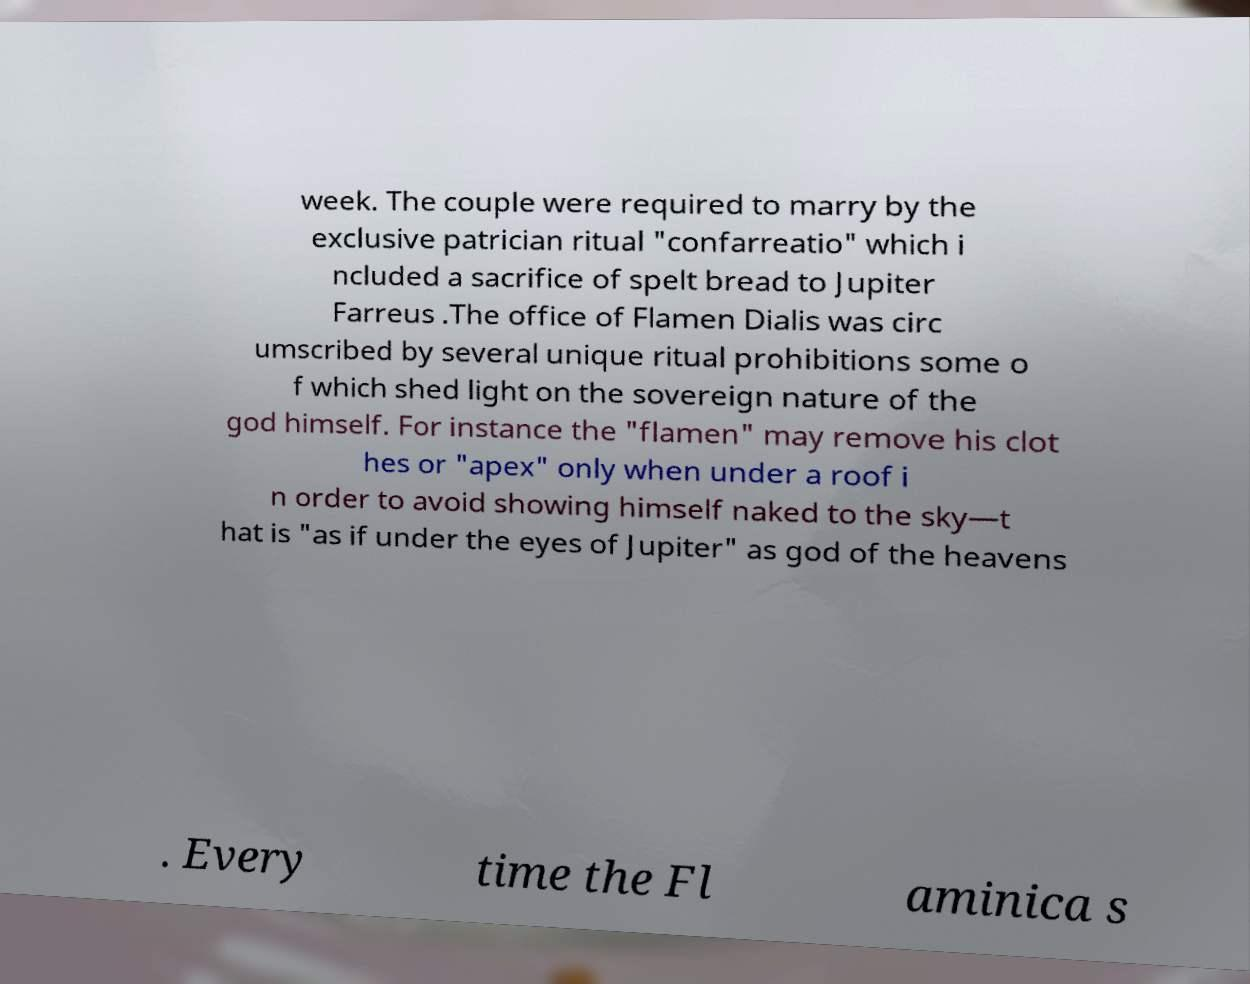There's text embedded in this image that I need extracted. Can you transcribe it verbatim? week. The couple were required to marry by the exclusive patrician ritual "confarreatio" which i ncluded a sacrifice of spelt bread to Jupiter Farreus .The office of Flamen Dialis was circ umscribed by several unique ritual prohibitions some o f which shed light on the sovereign nature of the god himself. For instance the "flamen" may remove his clot hes or "apex" only when under a roof i n order to avoid showing himself naked to the sky—t hat is "as if under the eyes of Jupiter" as god of the heavens . Every time the Fl aminica s 